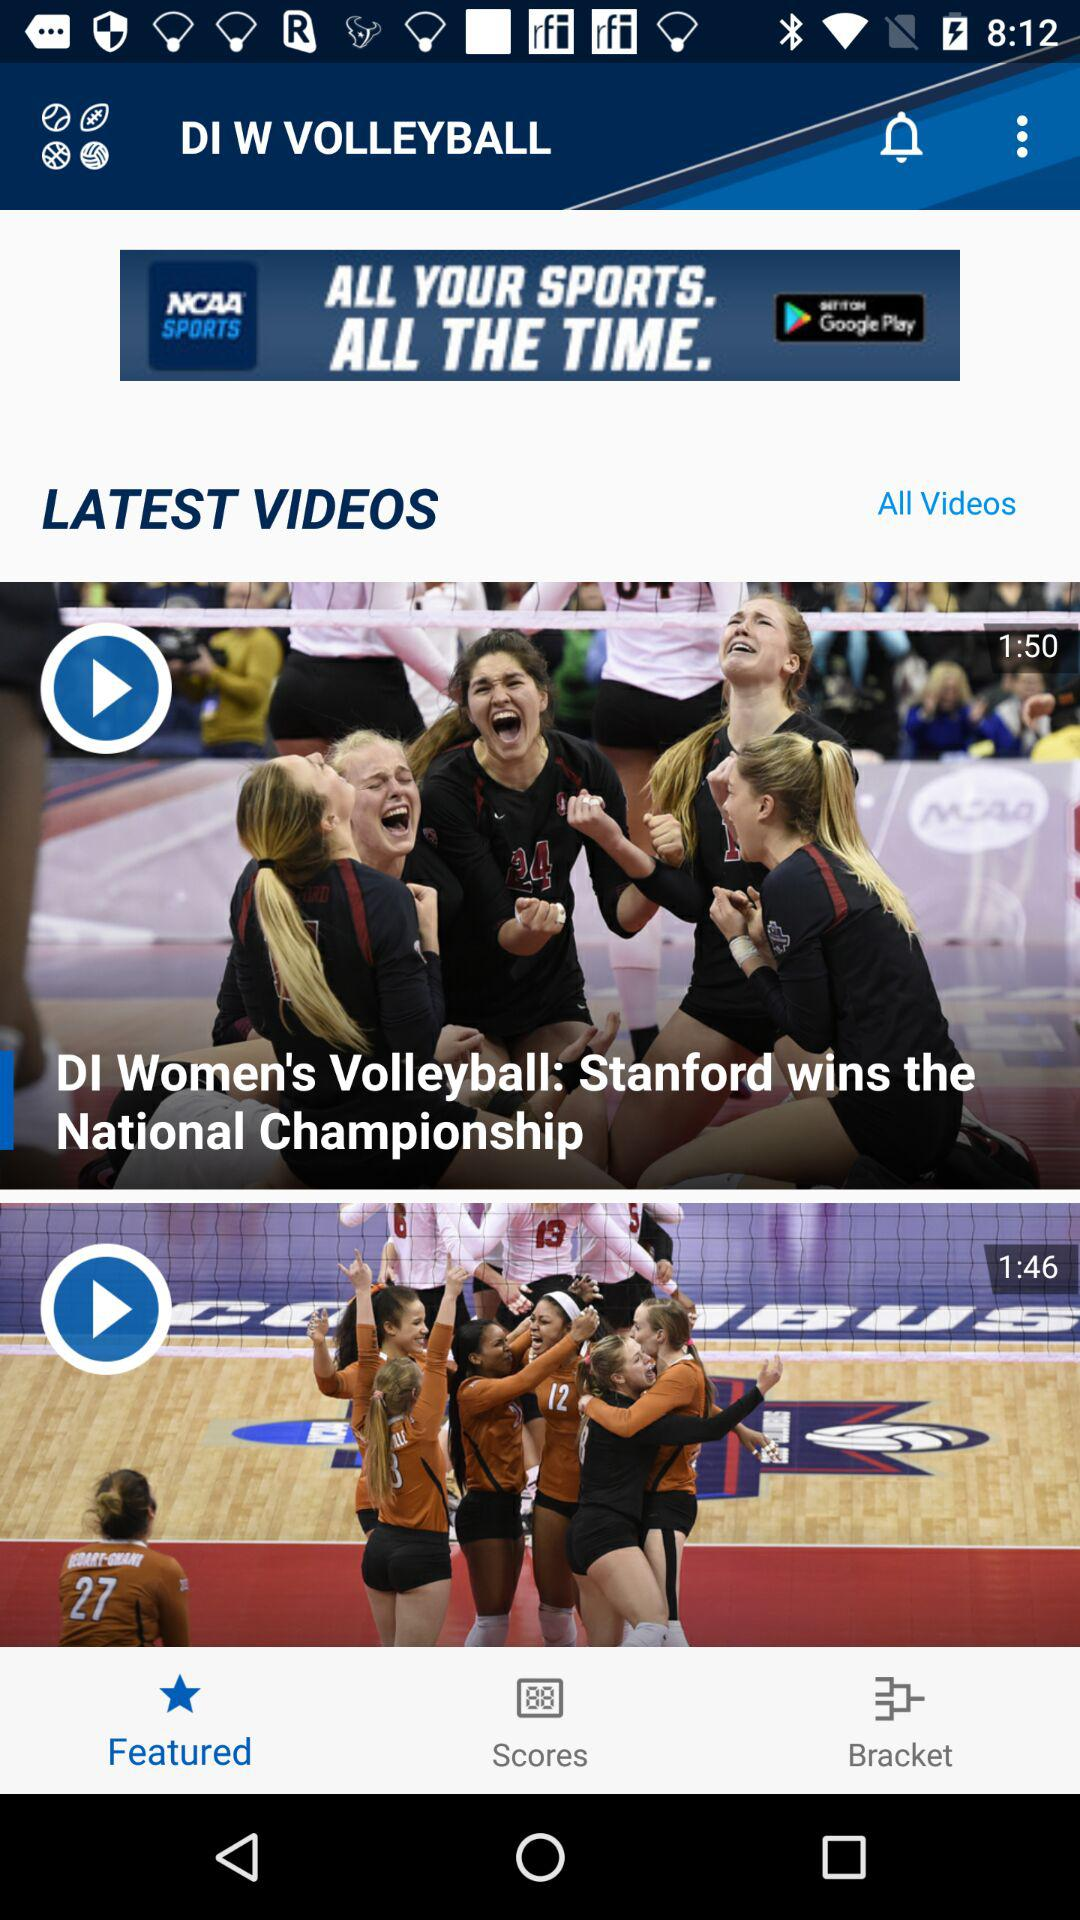What is the video length of "DI Women's Volleyball: Stanford wins the National Championship"? The length of the video is 1 minute and 50 seconds. 